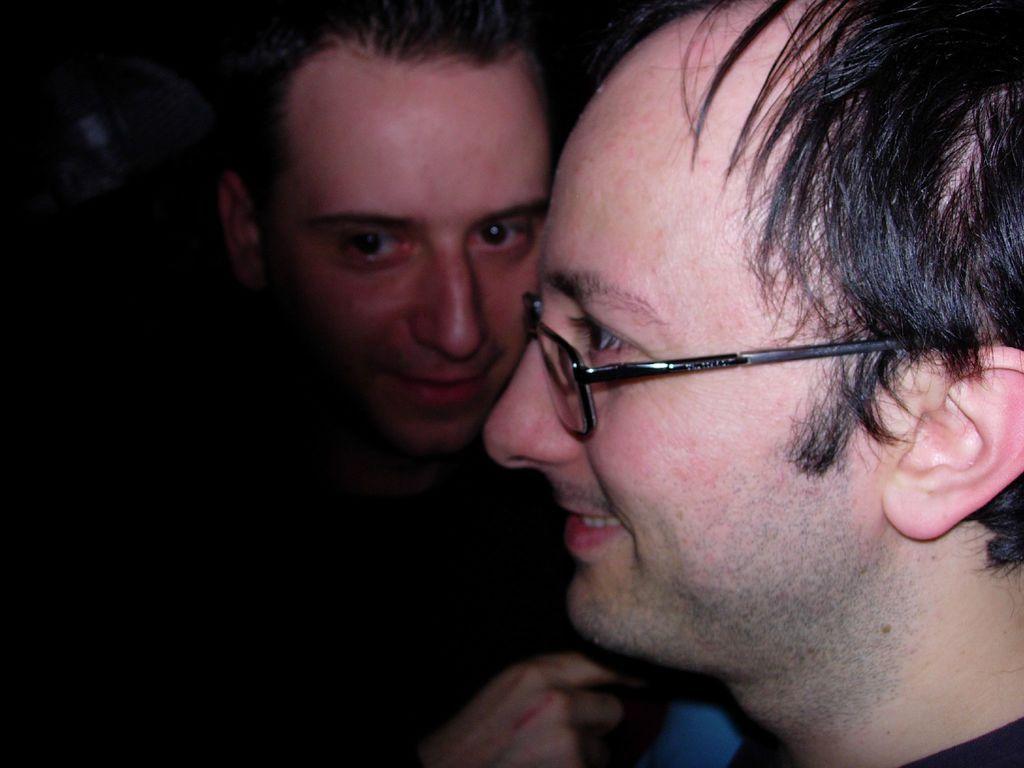Could you give a brief overview of what you see in this image? On the right side of the image there are two men and the left side of the image is dark. 